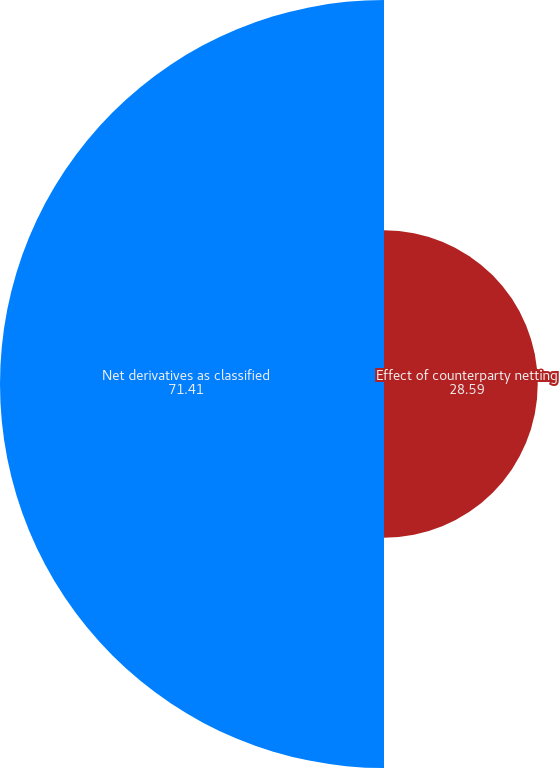<chart> <loc_0><loc_0><loc_500><loc_500><pie_chart><fcel>Effect of counterparty netting<fcel>Net derivatives as classified<nl><fcel>28.59%<fcel>71.41%<nl></chart> 